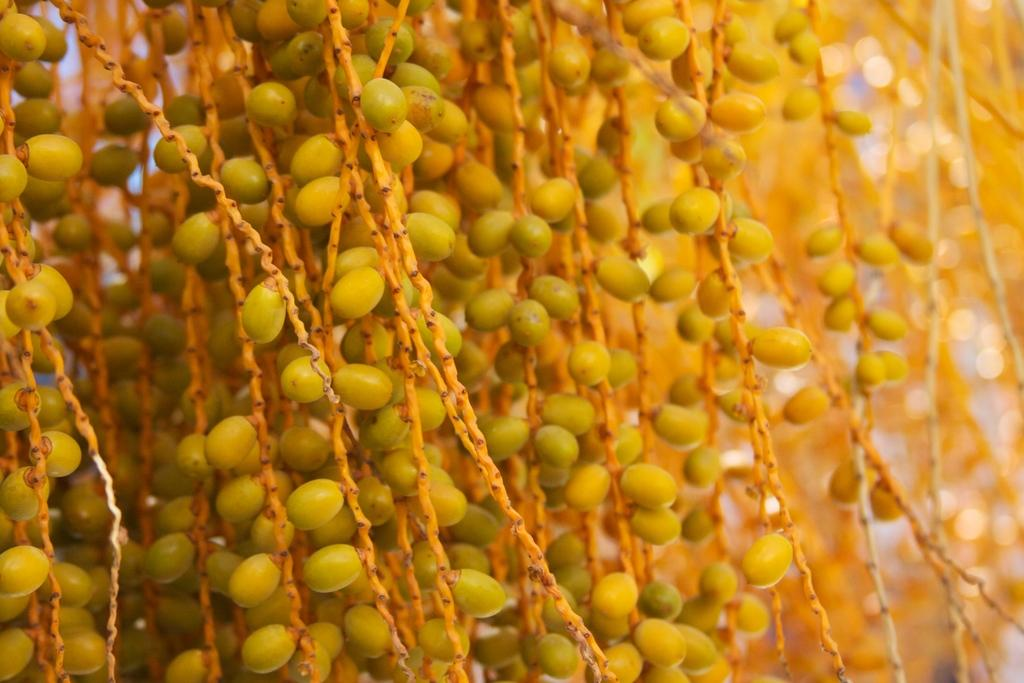What type of small objects can be seen in the image? There are seeds in the image. What body of water is visible in the image? There is no body of water present in the image; it only features seeds. 